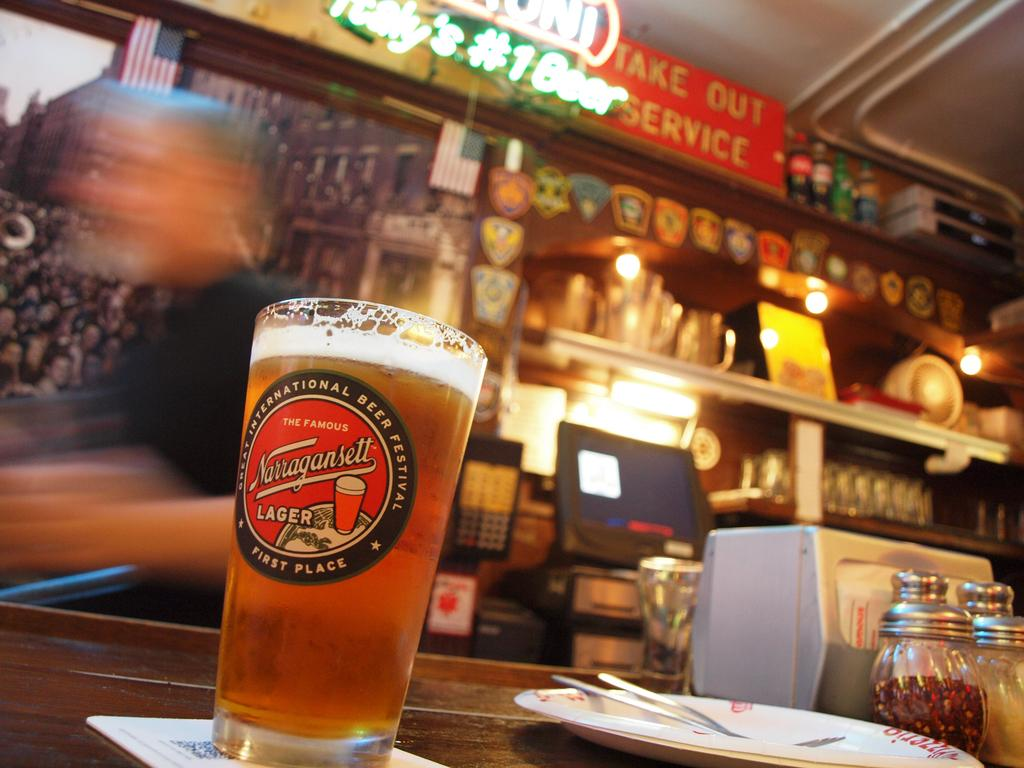<image>
Share a concise interpretation of the image provided. Above the bar is a sign that reads take out service. 